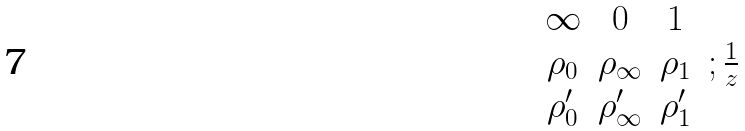Convert formula to latex. <formula><loc_0><loc_0><loc_500><loc_500>\begin{matrix} \infty & 0 & 1 & \\ \rho _ { 0 } & \rho _ { \infty } & \rho _ { 1 } & ; \frac { 1 } { z } \\ \rho _ { 0 } ^ { \prime } & \rho _ { \infty } ^ { \prime } & \rho _ { 1 } ^ { \prime } & \end{matrix}</formula> 